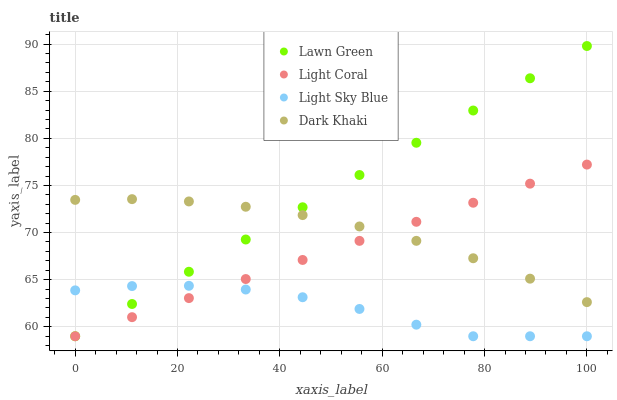Does Light Sky Blue have the minimum area under the curve?
Answer yes or no. Yes. Does Lawn Green have the maximum area under the curve?
Answer yes or no. Yes. Does Lawn Green have the minimum area under the curve?
Answer yes or no. No. Does Light Sky Blue have the maximum area under the curve?
Answer yes or no. No. Is Light Coral the smoothest?
Answer yes or no. Yes. Is Light Sky Blue the roughest?
Answer yes or no. Yes. Is Lawn Green the smoothest?
Answer yes or no. No. Is Lawn Green the roughest?
Answer yes or no. No. Does Light Coral have the lowest value?
Answer yes or no. Yes. Does Dark Khaki have the lowest value?
Answer yes or no. No. Does Lawn Green have the highest value?
Answer yes or no. Yes. Does Light Sky Blue have the highest value?
Answer yes or no. No. Is Light Sky Blue less than Dark Khaki?
Answer yes or no. Yes. Is Dark Khaki greater than Light Sky Blue?
Answer yes or no. Yes. Does Dark Khaki intersect Lawn Green?
Answer yes or no. Yes. Is Dark Khaki less than Lawn Green?
Answer yes or no. No. Is Dark Khaki greater than Lawn Green?
Answer yes or no. No. Does Light Sky Blue intersect Dark Khaki?
Answer yes or no. No. 